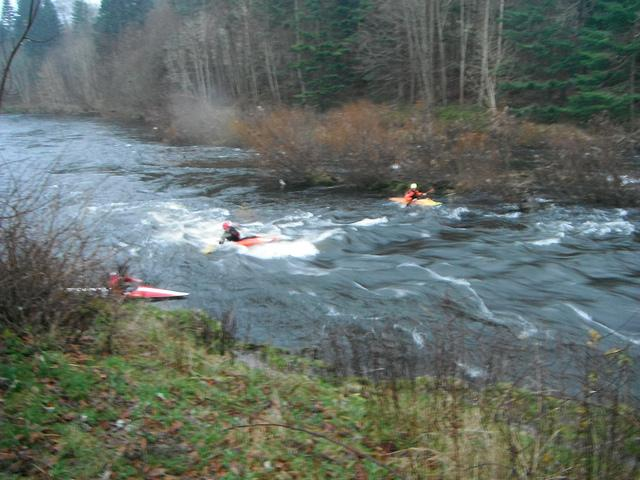Which direction are kayakers facing? downstream 